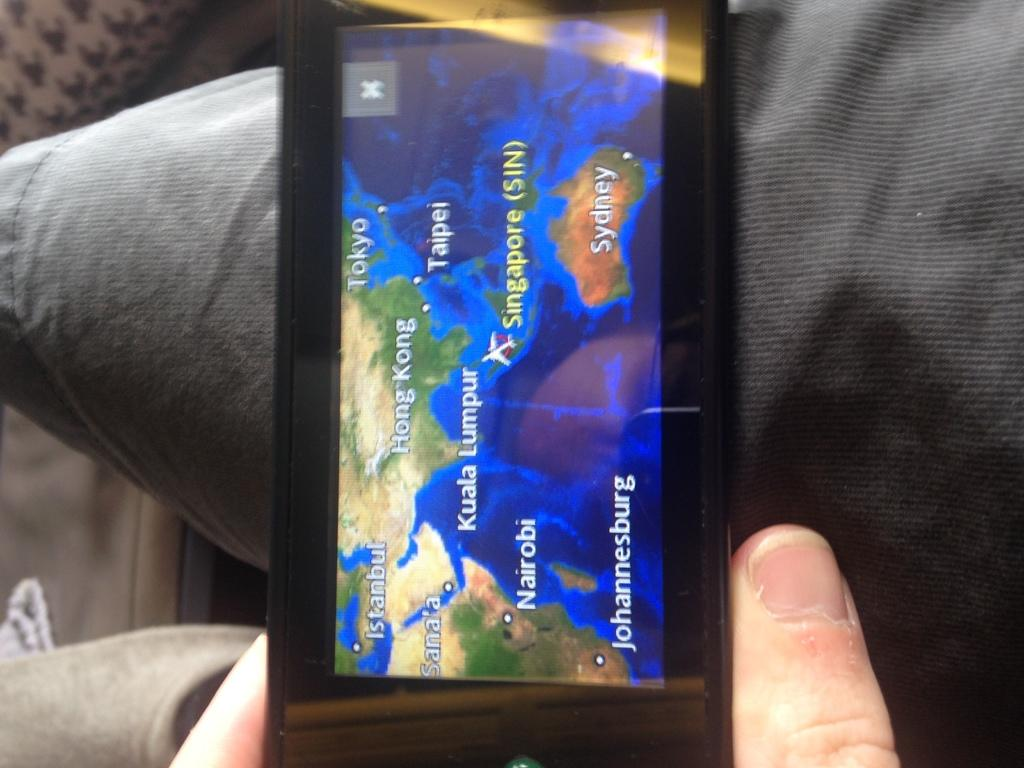<image>
Offer a succinct explanation of the picture presented. On the map, the airplane is situated northwest of Sydney and east of Nairobi. 